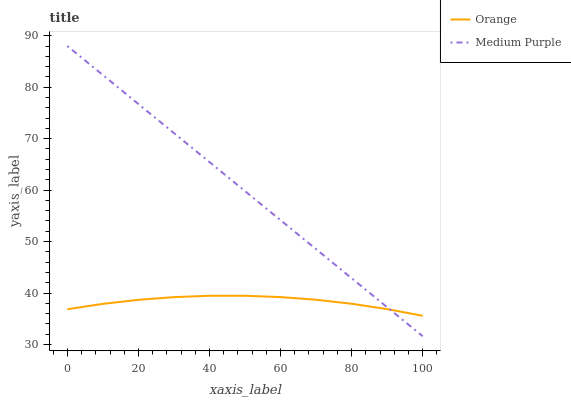Does Orange have the minimum area under the curve?
Answer yes or no. Yes. Does Medium Purple have the maximum area under the curve?
Answer yes or no. Yes. Does Medium Purple have the minimum area under the curve?
Answer yes or no. No. Is Medium Purple the smoothest?
Answer yes or no. Yes. Is Orange the roughest?
Answer yes or no. Yes. Is Medium Purple the roughest?
Answer yes or no. No. Does Medium Purple have the highest value?
Answer yes or no. Yes. Does Medium Purple intersect Orange?
Answer yes or no. Yes. Is Medium Purple less than Orange?
Answer yes or no. No. Is Medium Purple greater than Orange?
Answer yes or no. No. 